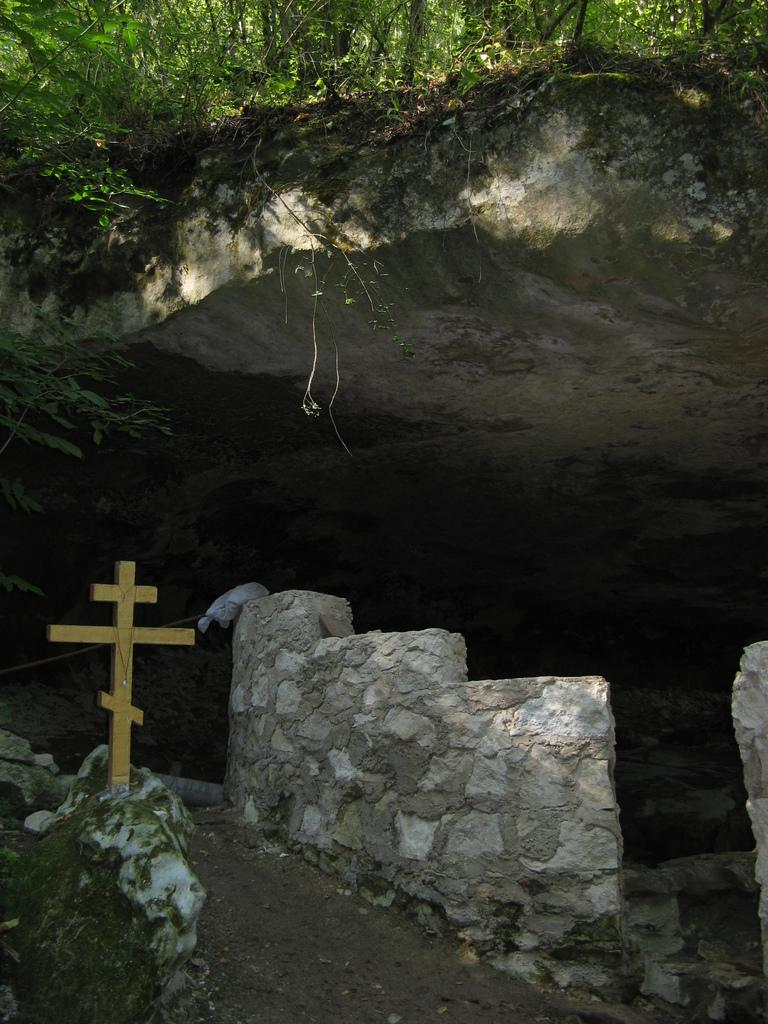What religious symbol is present in the image? There is a holly cross symbol in the image. What structure is located on the right side of the image? There is a wall on the right side of the image. What type of vegetation can be seen at the top of the image? There are trees visible at the top of the image. Where is the crib located in the image? There is no crib present in the image. What type of yard is visible in the image? There is no yard visible in the image. 